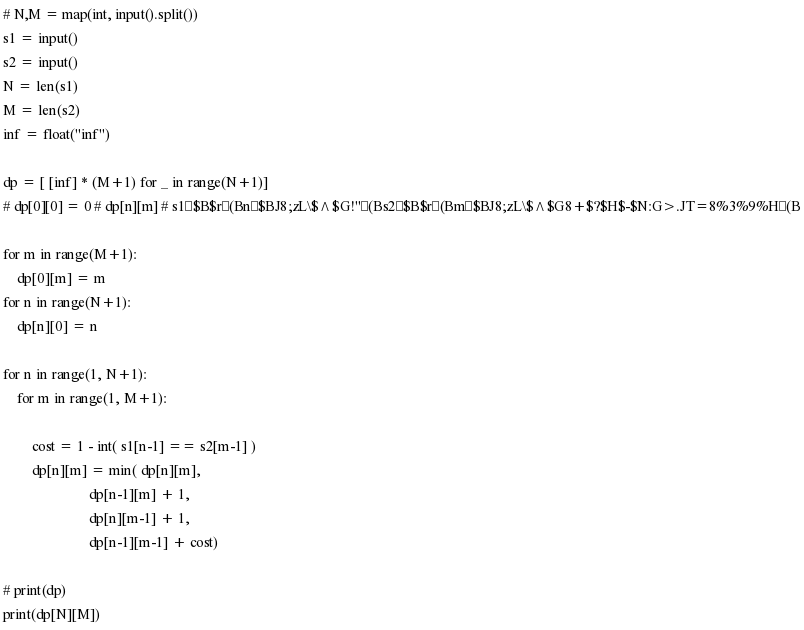Convert code to text. <code><loc_0><loc_0><loc_500><loc_500><_Python_># N,M = map(int, input().split())
s1 = input()
s2 = input()
N = len(s1)
M = len(s2)
inf = float("inf")

dp = [ [inf] * (M+1) for _ in range(N+1)]
# dp[0][0] = 0 # dp[n][m] # s1$B$r(Bn$BJ8;zL\$^$G!"(Bs2$B$r(Bm$BJ8;zL\$^$G8+$?$H$-$N:G>.JT=8%3%9%H(B

for m in range(M+1):
    dp[0][m] = m
for n in range(N+1):
    dp[n][0] = n

for n in range(1, N+1):
    for m in range(1, M+1):
        
        cost = 1 - int( s1[n-1] == s2[m-1] )
        dp[n][m] = min( dp[n][m], 
                        dp[n-1][m] + 1,
                        dp[n][m-1] + 1,
                        dp[n-1][m-1] + cost)

# print(dp)
print(dp[N][M])


</code> 